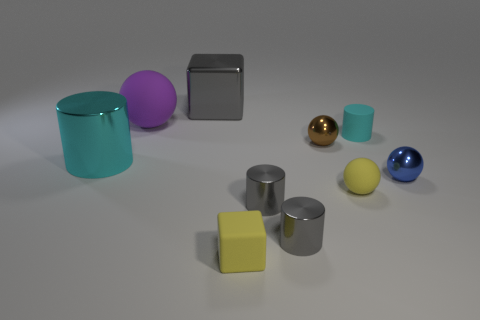What number of small things are either blocks or gray objects?
Your answer should be compact. 3. What number of other things are the same size as the metallic block?
Your answer should be very brief. 2. There is a large object in front of the big purple rubber sphere; is its shape the same as the cyan rubber thing?
Offer a terse response. Yes. What color is the other rubber object that is the same shape as the large matte object?
Provide a succinct answer. Yellow. Are there the same number of small yellow things that are left of the big ball and cyan matte cubes?
Offer a terse response. Yes. What number of small cylinders are both behind the brown sphere and to the left of the tiny brown thing?
Offer a very short reply. 0. There is a purple matte object that is the same shape as the tiny blue metal object; what size is it?
Provide a succinct answer. Large. How many purple spheres have the same material as the brown ball?
Offer a very short reply. 0. Is the number of purple objects in front of the big cylinder less than the number of big blocks?
Provide a short and direct response. Yes. How many tiny blue cylinders are there?
Your answer should be compact. 0. 